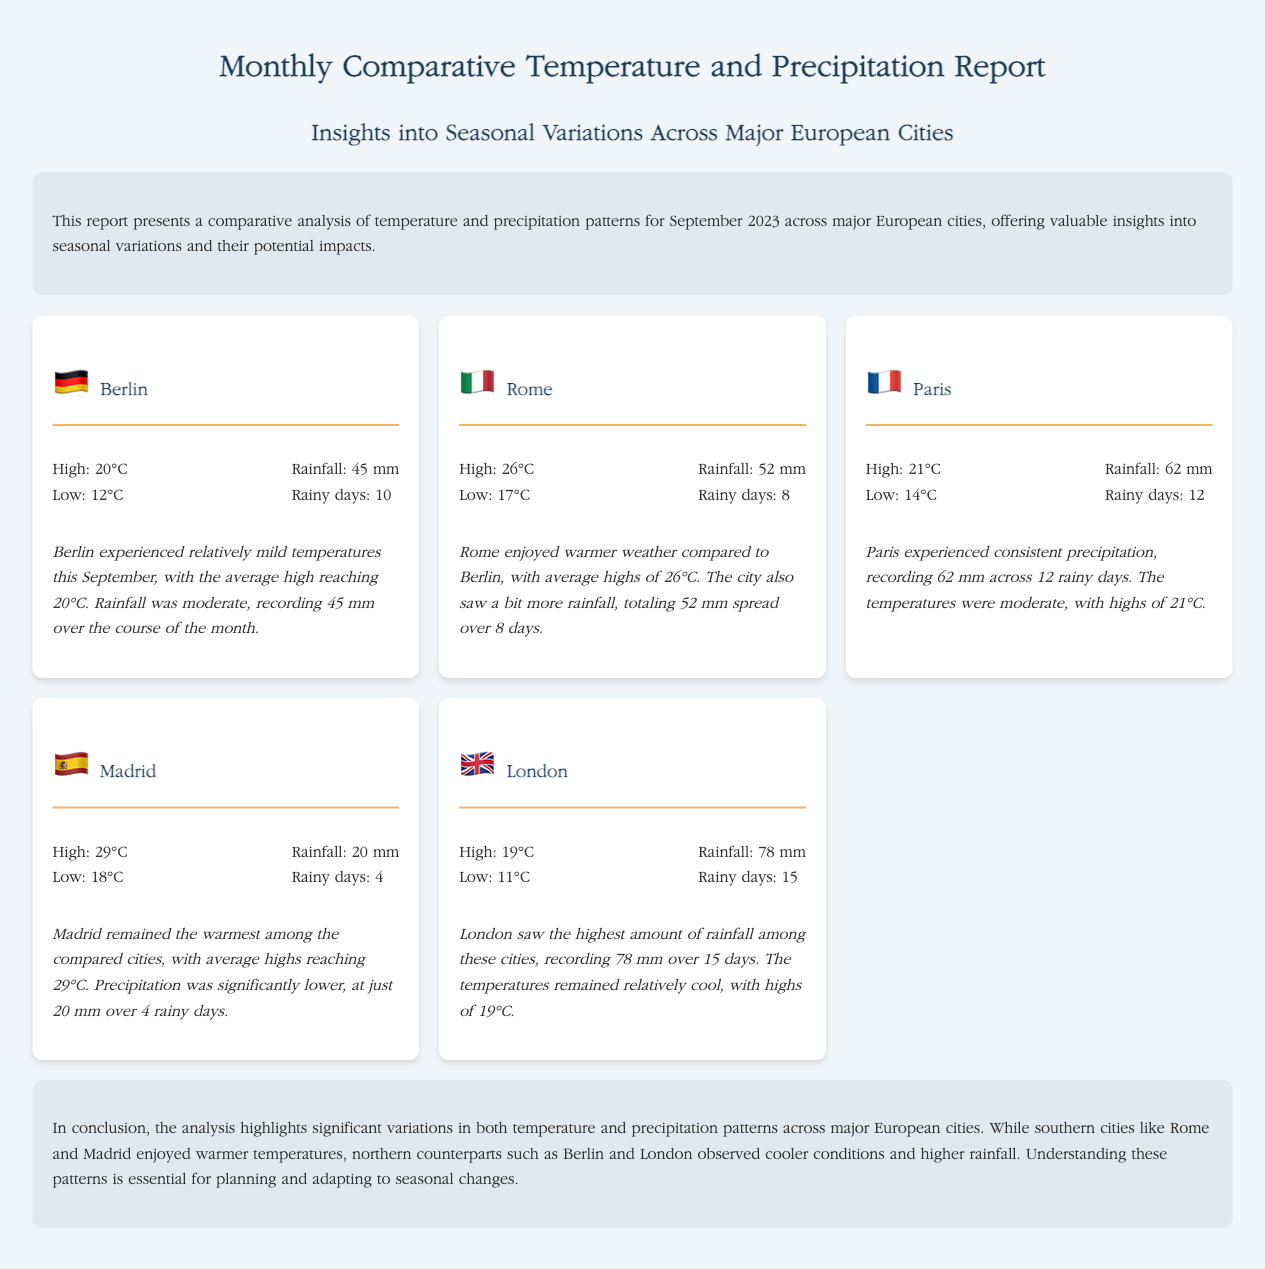what was the highest temperature recorded in Madrid? The highest temperature recorded in Madrid is 29°C, as stated in the summary for the city.
Answer: 29°C how much rainfall did Paris receive? The rainfall recorded in Paris is 62 mm, mentioned in the weather details for the city.
Answer: 62 mm how many rainy days did London experience? London experienced 15 rainy days, which is specified in the rainfall data for the city.
Answer: 15 which city had the lowest average high temperature? Berlin had the lowest average high temperature at 20°C, as reflected in the comparative summary.
Answer: Berlin which city recorded the highest precipitation? London recorded the highest precipitation with 78 mm, according to the information provided in the document.
Answer: London what is the average low temperature in Rome? The average low temperature in Rome is 17°C, as indicated in the city's weather report.
Answer: 17°C how does the temperature in Berlin compare to that in Madrid? Berlin's high of 20°C is cooler than Madrid's high of 29°C, showing that Madrid is warmer.
Answer: Cooler how many rainy days did Madrid have? Madrid had 4 rainy days, which is mentioned in the summary for precipitation in the city.
Answer: 4 what conclusion is drawn regarding seasonal variations? The conclusion highlights significant variations in temperature and precipitation across major cities.
Answer: Significant variations 